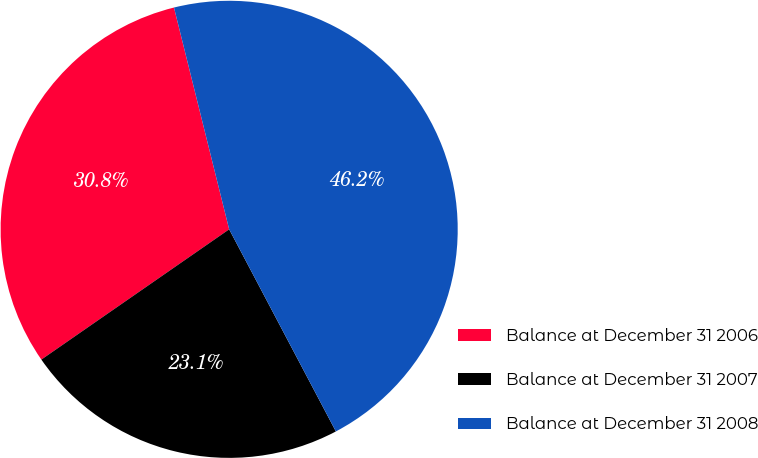Convert chart to OTSL. <chart><loc_0><loc_0><loc_500><loc_500><pie_chart><fcel>Balance at December 31 2006<fcel>Balance at December 31 2007<fcel>Balance at December 31 2008<nl><fcel>30.77%<fcel>23.08%<fcel>46.15%<nl></chart> 